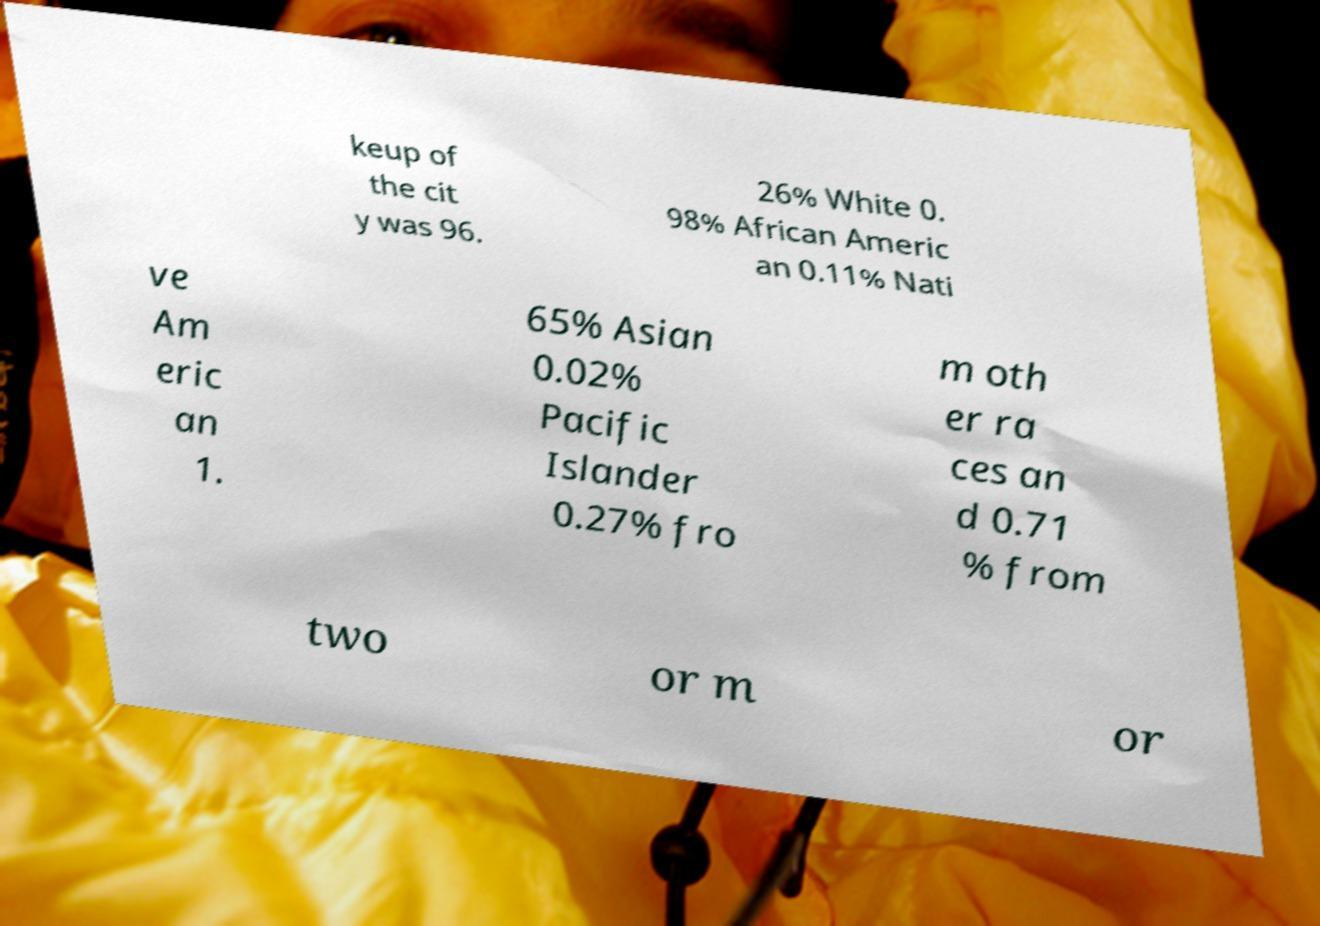Can you read and provide the text displayed in the image?This photo seems to have some interesting text. Can you extract and type it out for me? keup of the cit y was 96. 26% White 0. 98% African Americ an 0.11% Nati ve Am eric an 1. 65% Asian 0.02% Pacific Islander 0.27% fro m oth er ra ces an d 0.71 % from two or m or 